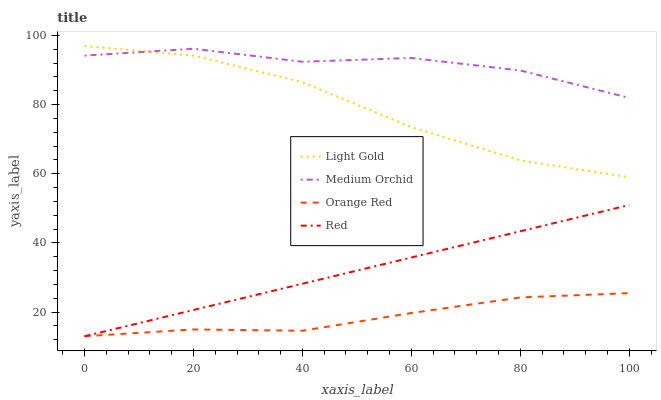Does Orange Red have the minimum area under the curve?
Answer yes or no. Yes. Does Medium Orchid have the maximum area under the curve?
Answer yes or no. Yes. Does Light Gold have the minimum area under the curve?
Answer yes or no. No. Does Light Gold have the maximum area under the curve?
Answer yes or no. No. Is Red the smoothest?
Answer yes or no. Yes. Is Medium Orchid the roughest?
Answer yes or no. Yes. Is Light Gold the smoothest?
Answer yes or no. No. Is Light Gold the roughest?
Answer yes or no. No. Does Orange Red have the lowest value?
Answer yes or no. Yes. Does Light Gold have the lowest value?
Answer yes or no. No. Does Light Gold have the highest value?
Answer yes or no. Yes. Does Orange Red have the highest value?
Answer yes or no. No. Is Red less than Medium Orchid?
Answer yes or no. Yes. Is Medium Orchid greater than Orange Red?
Answer yes or no. Yes. Does Red intersect Orange Red?
Answer yes or no. Yes. Is Red less than Orange Red?
Answer yes or no. No. Is Red greater than Orange Red?
Answer yes or no. No. Does Red intersect Medium Orchid?
Answer yes or no. No. 